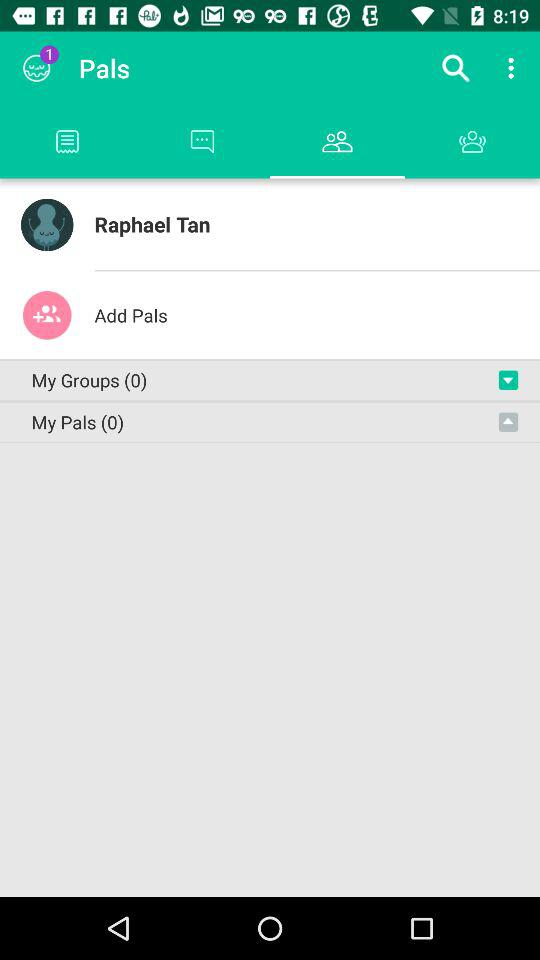How many my groups are there?
When the provided information is insufficient, respond with <no answer>. <no answer> 